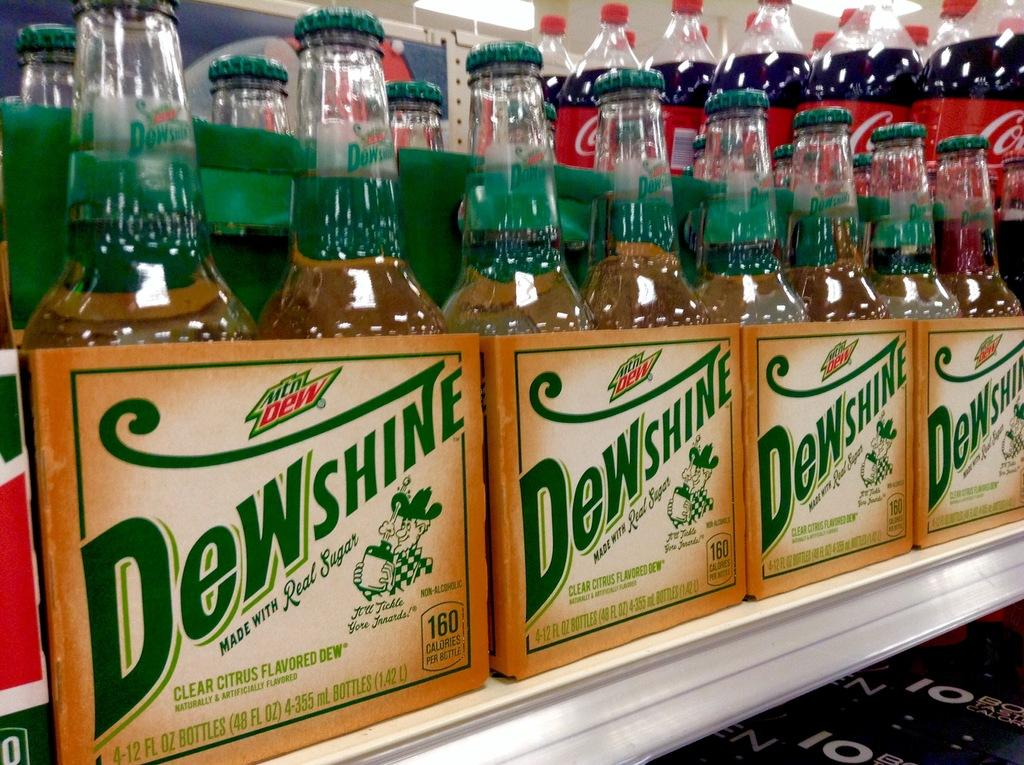<image>
Render a clear and concise summary of the photo. a shelf of bottled fruit drinks labelled Dewshire 